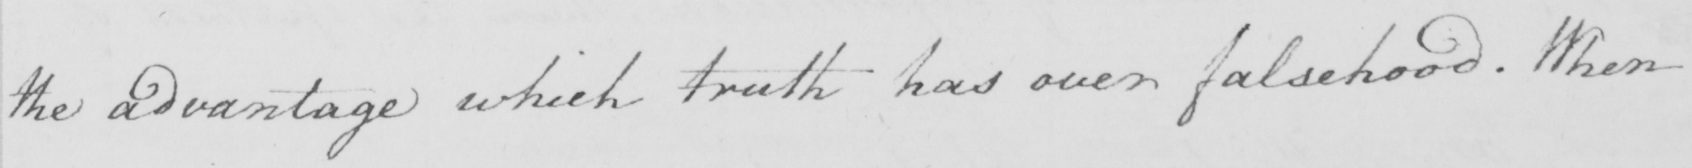Can you read and transcribe this handwriting? the advantage which truth has over falsehood . When 